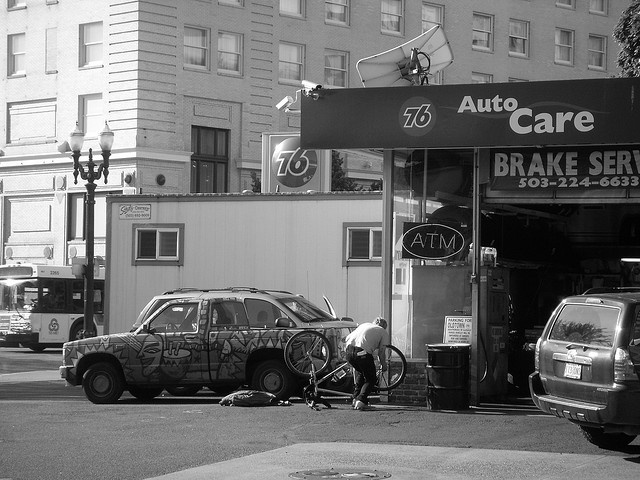Describe the objects in this image and their specific colors. I can see car in lightgray, black, gray, and darkgray tones, car in lightgray, black, gray, and darkgray tones, bus in lightgray, black, darkgray, and gray tones, bicycle in lightgray, black, gray, darkgray, and gainsboro tones, and people in lightgray, black, gray, white, and darkgray tones in this image. 